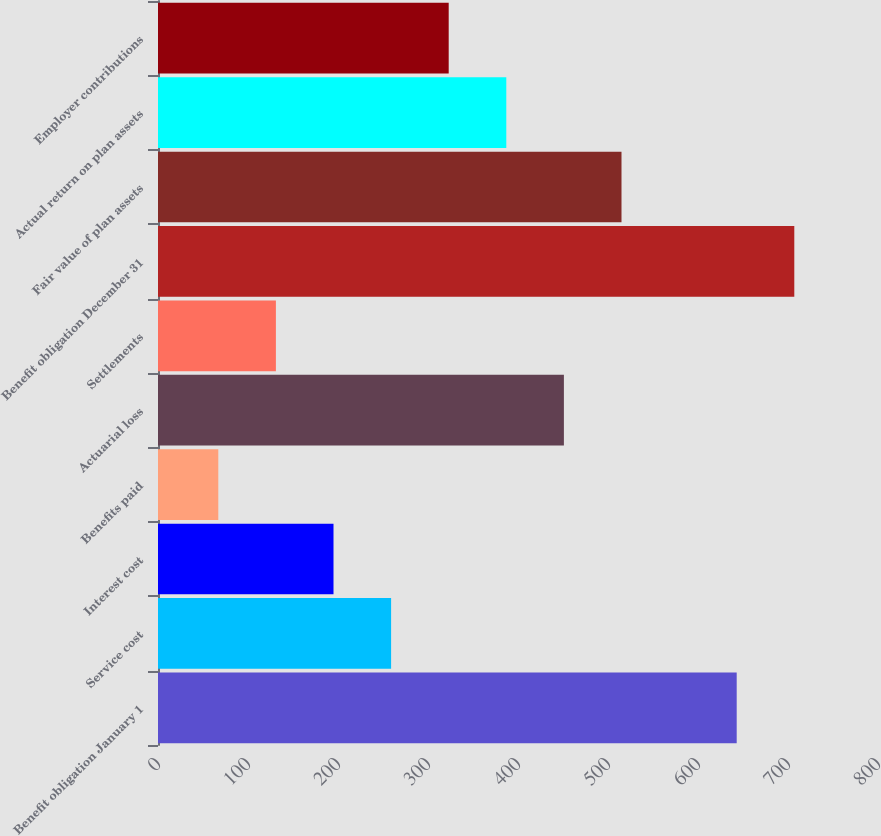Convert chart. <chart><loc_0><loc_0><loc_500><loc_500><bar_chart><fcel>Benefit obligation January 1<fcel>Service cost<fcel>Interest cost<fcel>Benefits paid<fcel>Actuarial loss<fcel>Settlements<fcel>Benefit obligation December 31<fcel>Fair value of plan assets<fcel>Actual return on plan assets<fcel>Employer contributions<nl><fcel>643<fcel>259<fcel>195<fcel>67<fcel>451<fcel>131<fcel>707<fcel>515<fcel>387<fcel>323<nl></chart> 